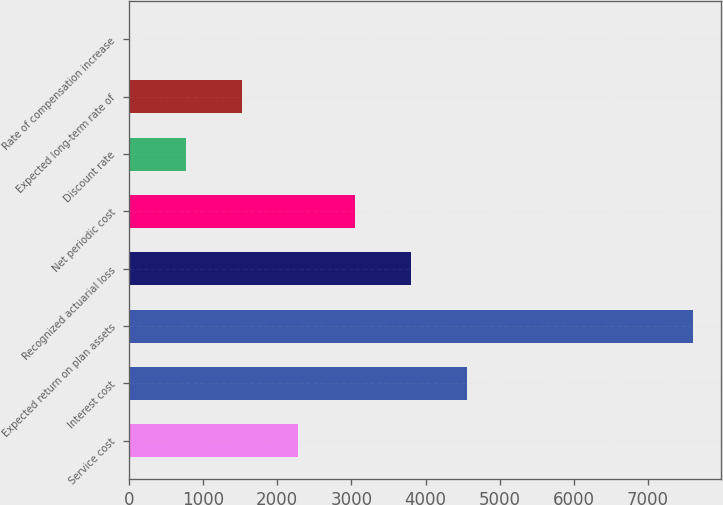<chart> <loc_0><loc_0><loc_500><loc_500><bar_chart><fcel>Service cost<fcel>Interest cost<fcel>Expected return on plan assets<fcel>Recognized actuarial loss<fcel>Net periodic cost<fcel>Discount rate<fcel>Expected long-term rate of<fcel>Rate of compensation increase<nl><fcel>2283.1<fcel>4562.2<fcel>7601<fcel>3802.5<fcel>3042.8<fcel>763.7<fcel>1523.4<fcel>4<nl></chart> 